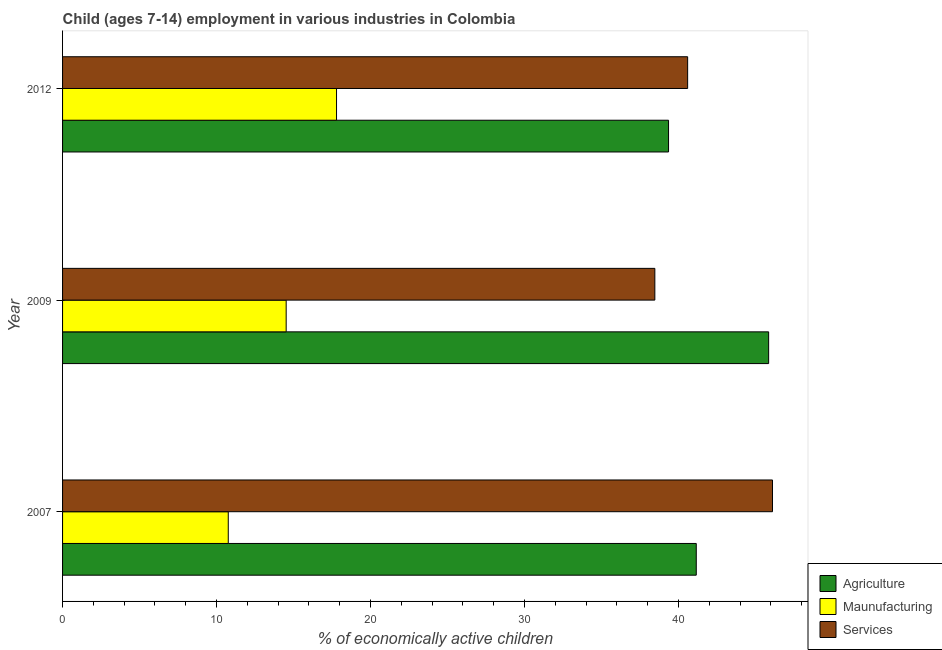How many different coloured bars are there?
Give a very brief answer. 3. Are the number of bars per tick equal to the number of legend labels?
Offer a terse response. Yes. How many bars are there on the 3rd tick from the top?
Provide a succinct answer. 3. How many bars are there on the 2nd tick from the bottom?
Ensure brevity in your answer.  3. In how many cases, is the number of bars for a given year not equal to the number of legend labels?
Offer a very short reply. 0. What is the percentage of economically active children in services in 2009?
Keep it short and to the point. 38.46. Across all years, what is the maximum percentage of economically active children in manufacturing?
Provide a short and direct response. 17.79. Across all years, what is the minimum percentage of economically active children in agriculture?
Offer a very short reply. 39.35. In which year was the percentage of economically active children in services maximum?
Provide a succinct answer. 2007. What is the total percentage of economically active children in agriculture in the graph?
Your answer should be very brief. 126.35. What is the difference between the percentage of economically active children in services in 2007 and that in 2009?
Provide a short and direct response. 7.64. What is the difference between the percentage of economically active children in services in 2009 and the percentage of economically active children in manufacturing in 2012?
Provide a short and direct response. 20.67. What is the average percentage of economically active children in manufacturing per year?
Offer a very short reply. 14.36. In the year 2009, what is the difference between the percentage of economically active children in services and percentage of economically active children in agriculture?
Provide a short and direct response. -7.39. What is the ratio of the percentage of economically active children in manufacturing in 2007 to that in 2012?
Make the answer very short. 0.6. Is the percentage of economically active children in agriculture in 2007 less than that in 2012?
Provide a short and direct response. No. What is the difference between the highest and the second highest percentage of economically active children in manufacturing?
Keep it short and to the point. 3.27. What is the difference between the highest and the lowest percentage of economically active children in agriculture?
Your answer should be very brief. 6.5. Is the sum of the percentage of economically active children in agriculture in 2007 and 2009 greater than the maximum percentage of economically active children in manufacturing across all years?
Make the answer very short. Yes. What does the 1st bar from the top in 2012 represents?
Offer a very short reply. Services. What does the 2nd bar from the bottom in 2007 represents?
Give a very brief answer. Maunufacturing. Is it the case that in every year, the sum of the percentage of economically active children in agriculture and percentage of economically active children in manufacturing is greater than the percentage of economically active children in services?
Keep it short and to the point. Yes. Are all the bars in the graph horizontal?
Ensure brevity in your answer.  Yes. How many years are there in the graph?
Make the answer very short. 3. What is the difference between two consecutive major ticks on the X-axis?
Offer a very short reply. 10. Are the values on the major ticks of X-axis written in scientific E-notation?
Make the answer very short. No. Does the graph contain any zero values?
Keep it short and to the point. No. Does the graph contain grids?
Provide a succinct answer. No. Where does the legend appear in the graph?
Keep it short and to the point. Bottom right. How are the legend labels stacked?
Provide a short and direct response. Vertical. What is the title of the graph?
Offer a very short reply. Child (ages 7-14) employment in various industries in Colombia. What is the label or title of the X-axis?
Keep it short and to the point. % of economically active children. What is the label or title of the Y-axis?
Your answer should be very brief. Year. What is the % of economically active children in Agriculture in 2007?
Your response must be concise. 41.15. What is the % of economically active children of Maunufacturing in 2007?
Provide a short and direct response. 10.76. What is the % of economically active children in Services in 2007?
Keep it short and to the point. 46.1. What is the % of economically active children in Agriculture in 2009?
Your answer should be very brief. 45.85. What is the % of economically active children in Maunufacturing in 2009?
Offer a very short reply. 14.52. What is the % of economically active children of Services in 2009?
Provide a short and direct response. 38.46. What is the % of economically active children of Agriculture in 2012?
Give a very brief answer. 39.35. What is the % of economically active children of Maunufacturing in 2012?
Make the answer very short. 17.79. What is the % of economically active children in Services in 2012?
Give a very brief answer. 40.59. Across all years, what is the maximum % of economically active children in Agriculture?
Ensure brevity in your answer.  45.85. Across all years, what is the maximum % of economically active children in Maunufacturing?
Your response must be concise. 17.79. Across all years, what is the maximum % of economically active children in Services?
Your answer should be compact. 46.1. Across all years, what is the minimum % of economically active children in Agriculture?
Offer a very short reply. 39.35. Across all years, what is the minimum % of economically active children in Maunufacturing?
Make the answer very short. 10.76. Across all years, what is the minimum % of economically active children in Services?
Offer a terse response. 38.46. What is the total % of economically active children of Agriculture in the graph?
Make the answer very short. 126.35. What is the total % of economically active children of Maunufacturing in the graph?
Offer a very short reply. 43.07. What is the total % of economically active children of Services in the graph?
Provide a succinct answer. 125.15. What is the difference between the % of economically active children in Agriculture in 2007 and that in 2009?
Offer a terse response. -4.7. What is the difference between the % of economically active children in Maunufacturing in 2007 and that in 2009?
Ensure brevity in your answer.  -3.76. What is the difference between the % of economically active children in Services in 2007 and that in 2009?
Your answer should be compact. 7.64. What is the difference between the % of economically active children of Agriculture in 2007 and that in 2012?
Provide a succinct answer. 1.8. What is the difference between the % of economically active children in Maunufacturing in 2007 and that in 2012?
Your response must be concise. -7.03. What is the difference between the % of economically active children of Services in 2007 and that in 2012?
Offer a very short reply. 5.51. What is the difference between the % of economically active children in Agriculture in 2009 and that in 2012?
Keep it short and to the point. 6.5. What is the difference between the % of economically active children in Maunufacturing in 2009 and that in 2012?
Your answer should be compact. -3.27. What is the difference between the % of economically active children of Services in 2009 and that in 2012?
Make the answer very short. -2.13. What is the difference between the % of economically active children in Agriculture in 2007 and the % of economically active children in Maunufacturing in 2009?
Ensure brevity in your answer.  26.63. What is the difference between the % of economically active children of Agriculture in 2007 and the % of economically active children of Services in 2009?
Your answer should be compact. 2.69. What is the difference between the % of economically active children in Maunufacturing in 2007 and the % of economically active children in Services in 2009?
Your response must be concise. -27.7. What is the difference between the % of economically active children in Agriculture in 2007 and the % of economically active children in Maunufacturing in 2012?
Keep it short and to the point. 23.36. What is the difference between the % of economically active children in Agriculture in 2007 and the % of economically active children in Services in 2012?
Give a very brief answer. 0.56. What is the difference between the % of economically active children in Maunufacturing in 2007 and the % of economically active children in Services in 2012?
Your answer should be very brief. -29.83. What is the difference between the % of economically active children in Agriculture in 2009 and the % of economically active children in Maunufacturing in 2012?
Provide a short and direct response. 28.06. What is the difference between the % of economically active children in Agriculture in 2009 and the % of economically active children in Services in 2012?
Keep it short and to the point. 5.26. What is the difference between the % of economically active children of Maunufacturing in 2009 and the % of economically active children of Services in 2012?
Your answer should be compact. -26.07. What is the average % of economically active children of Agriculture per year?
Offer a terse response. 42.12. What is the average % of economically active children in Maunufacturing per year?
Your answer should be compact. 14.36. What is the average % of economically active children of Services per year?
Your response must be concise. 41.72. In the year 2007, what is the difference between the % of economically active children of Agriculture and % of economically active children of Maunufacturing?
Give a very brief answer. 30.39. In the year 2007, what is the difference between the % of economically active children in Agriculture and % of economically active children in Services?
Keep it short and to the point. -4.95. In the year 2007, what is the difference between the % of economically active children of Maunufacturing and % of economically active children of Services?
Ensure brevity in your answer.  -35.34. In the year 2009, what is the difference between the % of economically active children in Agriculture and % of economically active children in Maunufacturing?
Offer a terse response. 31.33. In the year 2009, what is the difference between the % of economically active children in Agriculture and % of economically active children in Services?
Provide a succinct answer. 7.39. In the year 2009, what is the difference between the % of economically active children of Maunufacturing and % of economically active children of Services?
Make the answer very short. -23.94. In the year 2012, what is the difference between the % of economically active children in Agriculture and % of economically active children in Maunufacturing?
Keep it short and to the point. 21.56. In the year 2012, what is the difference between the % of economically active children in Agriculture and % of economically active children in Services?
Your answer should be very brief. -1.24. In the year 2012, what is the difference between the % of economically active children of Maunufacturing and % of economically active children of Services?
Ensure brevity in your answer.  -22.8. What is the ratio of the % of economically active children in Agriculture in 2007 to that in 2009?
Make the answer very short. 0.9. What is the ratio of the % of economically active children of Maunufacturing in 2007 to that in 2009?
Provide a succinct answer. 0.74. What is the ratio of the % of economically active children in Services in 2007 to that in 2009?
Your answer should be very brief. 1.2. What is the ratio of the % of economically active children of Agriculture in 2007 to that in 2012?
Give a very brief answer. 1.05. What is the ratio of the % of economically active children in Maunufacturing in 2007 to that in 2012?
Offer a terse response. 0.6. What is the ratio of the % of economically active children in Services in 2007 to that in 2012?
Ensure brevity in your answer.  1.14. What is the ratio of the % of economically active children of Agriculture in 2009 to that in 2012?
Offer a terse response. 1.17. What is the ratio of the % of economically active children in Maunufacturing in 2009 to that in 2012?
Offer a terse response. 0.82. What is the ratio of the % of economically active children in Services in 2009 to that in 2012?
Your answer should be compact. 0.95. What is the difference between the highest and the second highest % of economically active children in Maunufacturing?
Your response must be concise. 3.27. What is the difference between the highest and the second highest % of economically active children in Services?
Provide a succinct answer. 5.51. What is the difference between the highest and the lowest % of economically active children of Agriculture?
Keep it short and to the point. 6.5. What is the difference between the highest and the lowest % of economically active children of Maunufacturing?
Provide a short and direct response. 7.03. What is the difference between the highest and the lowest % of economically active children in Services?
Offer a very short reply. 7.64. 